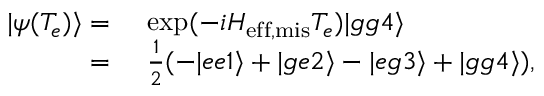Convert formula to latex. <formula><loc_0><loc_0><loc_500><loc_500>\begin{array} { r l } { | \psi ( T _ { e } ) \rangle = } & e x p ( - i H _ { e f f , m i s } T _ { e } ) | g g 4 \rangle } \\ { = } & \frac { 1 } { 2 } ( - | e e 1 \rangle + | g e 2 \rangle - | e g 3 \rangle + | g g 4 \rangle ) , } \end{array}</formula> 